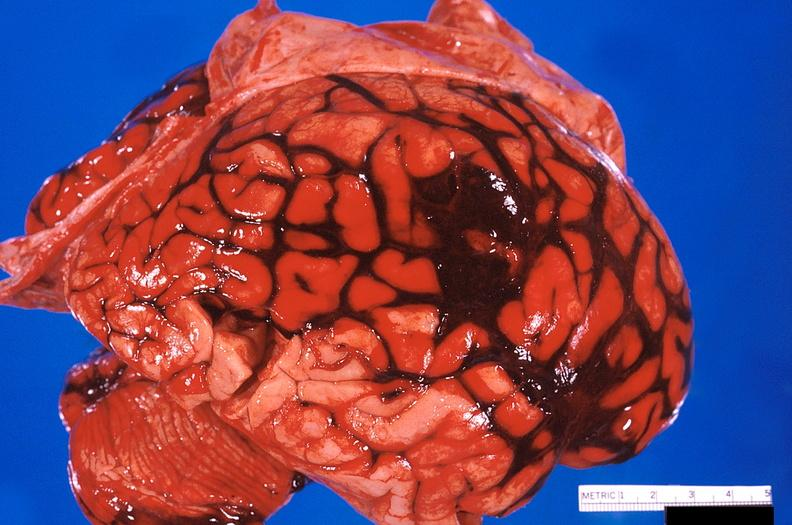does this image show brain, subarachanoid hemorrhage due to ruptured aneurysm?
Answer the question using a single word or phrase. Yes 